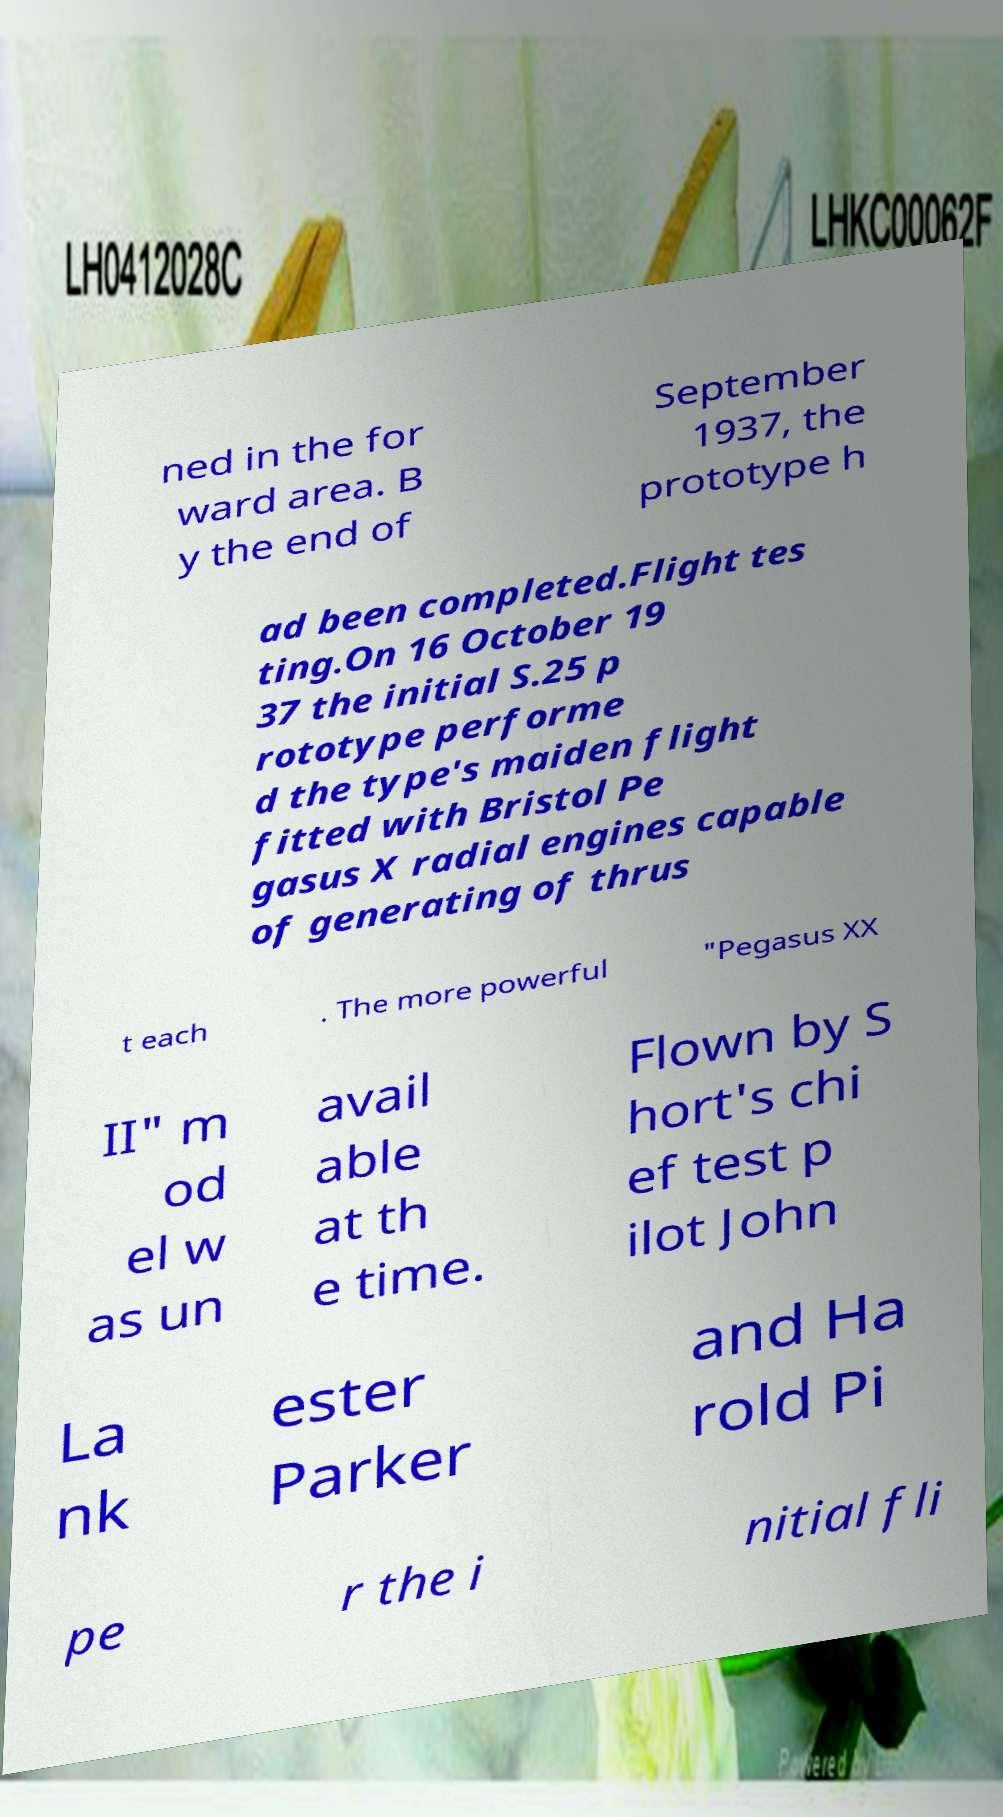Can you accurately transcribe the text from the provided image for me? ned in the for ward area. B y the end of September 1937, the prototype h ad been completed.Flight tes ting.On 16 October 19 37 the initial S.25 p rototype performe d the type's maiden flight fitted with Bristol Pe gasus X radial engines capable of generating of thrus t each . The more powerful "Pegasus XX II" m od el w as un avail able at th e time. Flown by S hort's chi ef test p ilot John La nk ester Parker and Ha rold Pi pe r the i nitial fli 